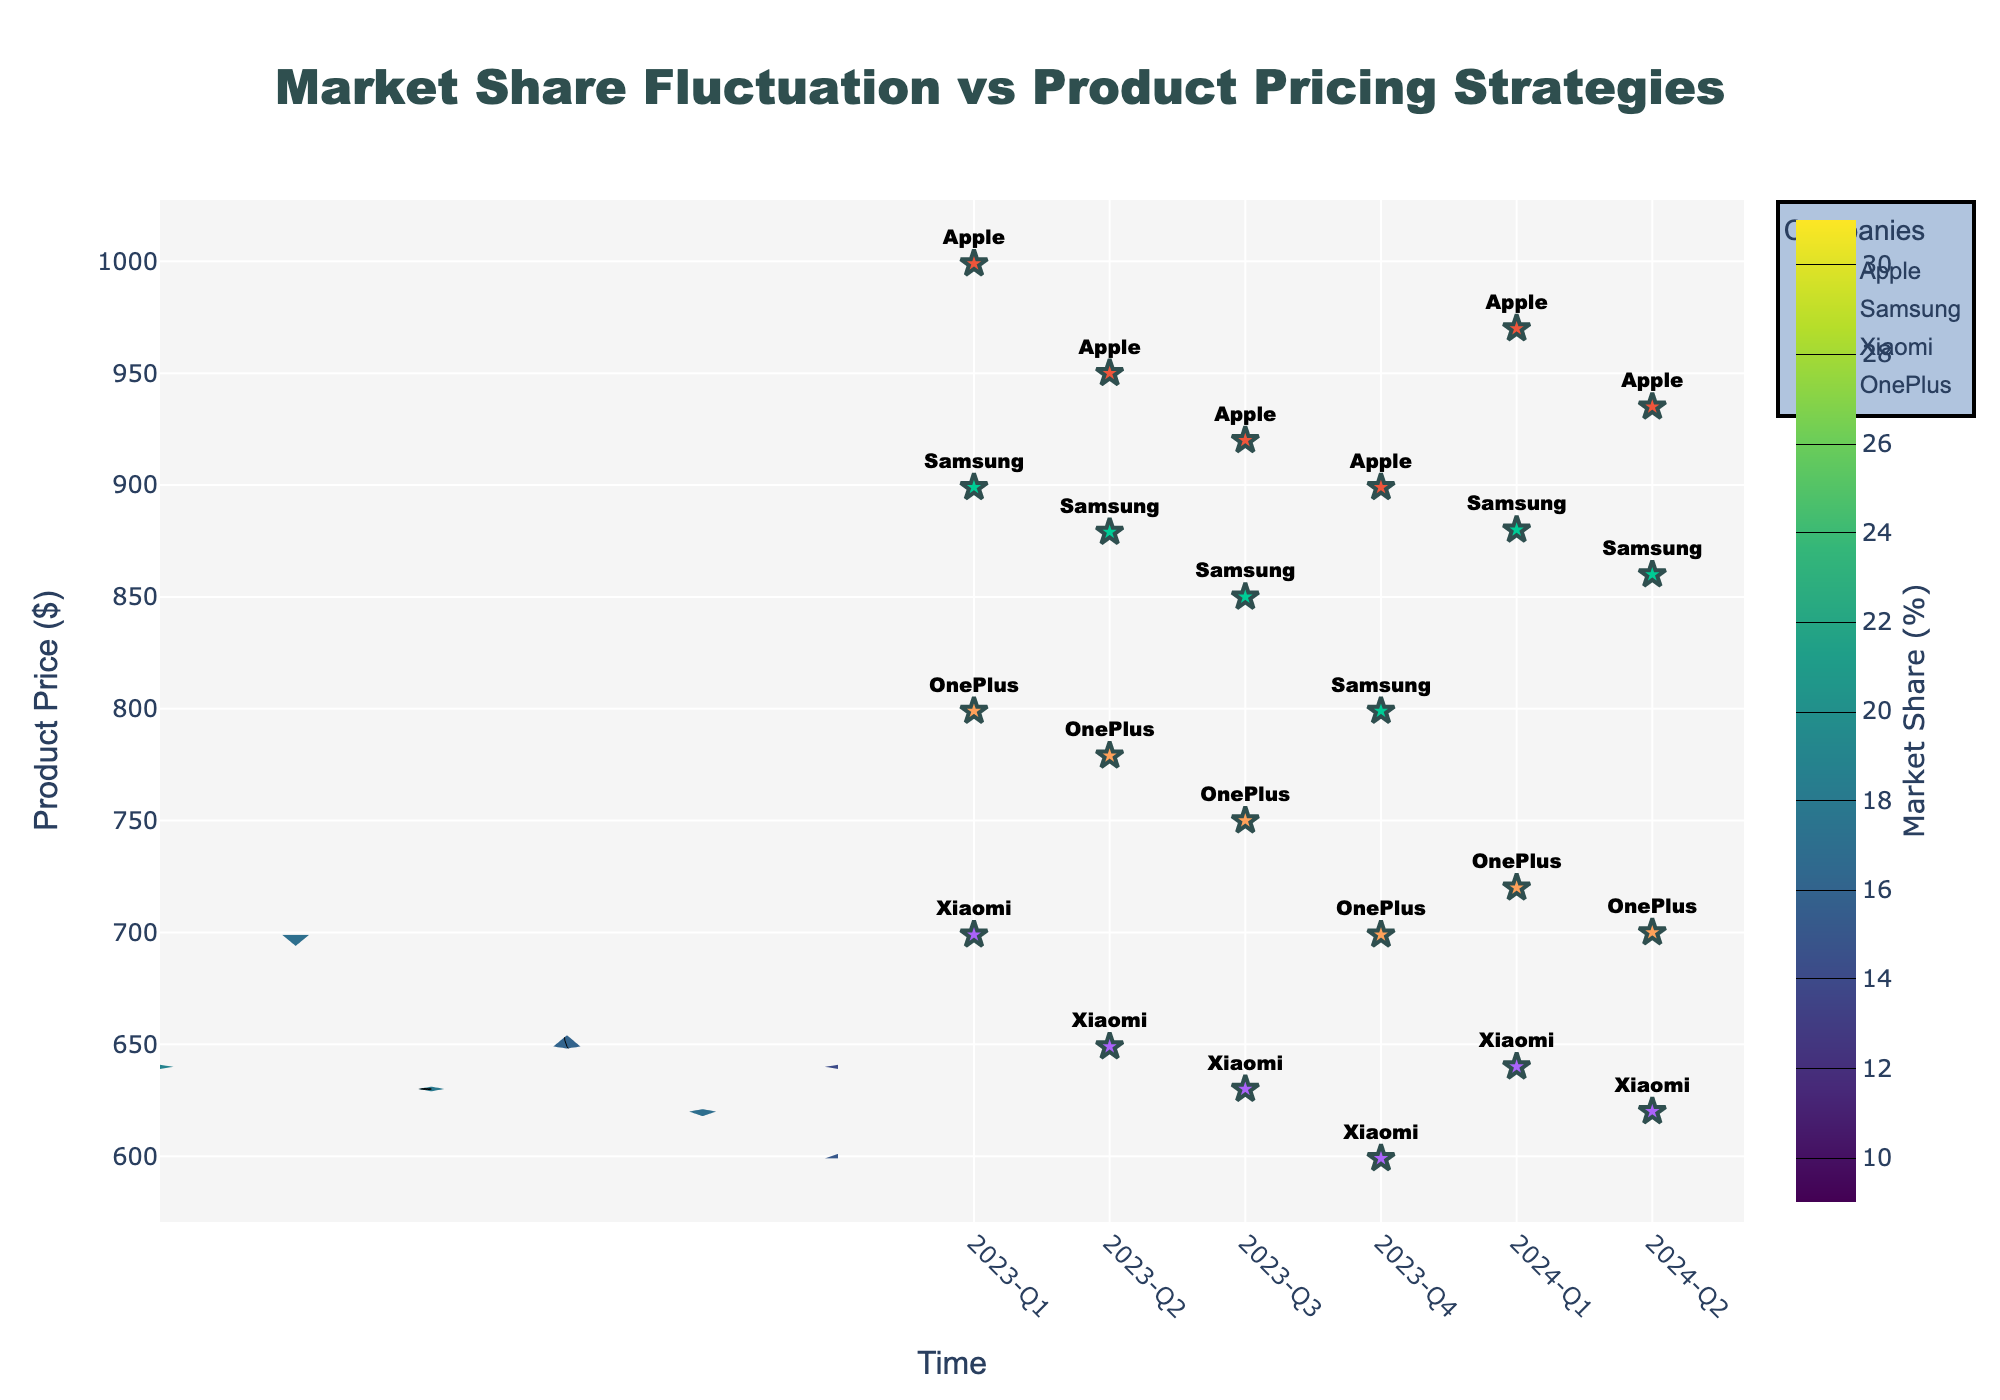What is the title of the figure? The title is usually displayed at the top of the figure. In this case, the title displayed is "Market Share Fluctuation vs Product Pricing Strategies".
Answer: Market Share Fluctuation vs Product Pricing Strategies What does the colorbar represent in the figure? The colorbar typically indicates the range of values represented by different colors in the contour plot. Here, it shows the market share percentage in different shades of color.
Answer: Market Share (%) How many companies are plotted on the figure? Each company is represented by markers in the figure. Based on the provided data, the companies are Apple, Samsung, Xiaomi, and OnePlus, making a total of four companies.
Answer: 4 Between which two quarters does Apple show the highest increase in market share? By observing the Apple data points in the figure, we can see the market share percentage change over time. Apple shows the highest increase between "2023-Q3" and "2023-Q4" from 24% to 26%.
Answer: 2023-Q3 and 2023-Q4 Which company had the lowest product price in 2024-Q2? By looking at the markers for 2024-Q2 and their corresponding labels, Xiaomi had the lowest product price at $620.
Answer: Xiaomi On average, how does product price correlate with market share over the entire time period? To determine this, we glance at the contour gradients. Higher market share tends to be associated with lower product prices, indicating an inverse correlation.
Answer: Inversely correlated Which company had the most significant drop in market share from 2023-Q1 to 2023-Q2? Comparing the market share values for each company between these two quarters, Apple dropped from 25% to 23%, indicating a significant reduction. However, Xiaomi's share increased, and the drop by Apple remains notably significant.
Answer: Apple What pattern can be observed for Samsung’s market share as the product price decreases from 2023-Q1 to 2024-Q2? Samsung’s market share increases as the product price decreases across the given period. This is evident by comparing market share and product price over time for Samsung.
Answer: Market share increases with decreasing product price How did OnePlus's market share trend compare to Xiaomi's from 2023-Q1 to 2024-Q2? By examining the markers and their respective changes over time, OnePlus's market share shows a lesser increase compared to Xiaomi's, which had a consistent increase in market share as their product price decreased.
Answer: Less significant increase What is the highest recorded market share for any company, and when did it occur? Observing the highest contour value and the scatter markers, Apple's market share reached 26% in 2023-Q4, which is the highest recorded market share.
Answer: 26% in 2023-Q4 